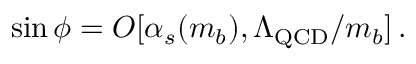<formula> <loc_0><loc_0><loc_500><loc_500>\sin \phi = O [ \alpha _ { s } ( m _ { b } ) , \Lambda _ { Q C D } / m _ { b } ] \, .</formula> 